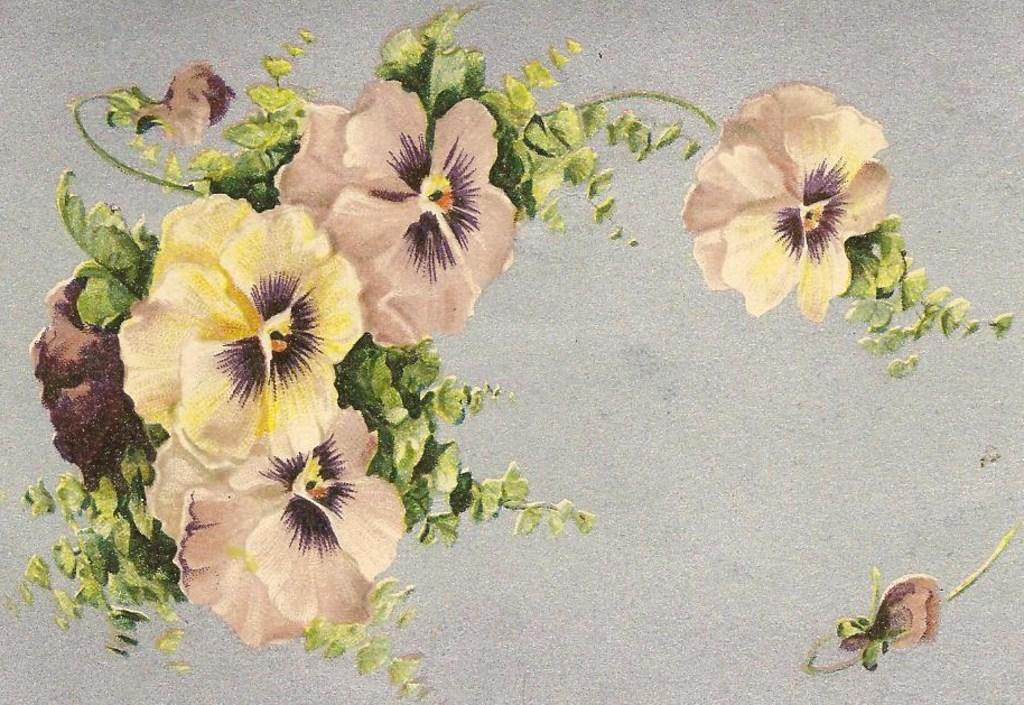What type of artwork is depicted in the image? The image is a painting. What natural elements can be seen in the painting? There are flowers and leaves in the painting. What type of fruit is being held by the sister in the painting? There is no sister or fruit present in the painting; it only features flowers and leaves. 